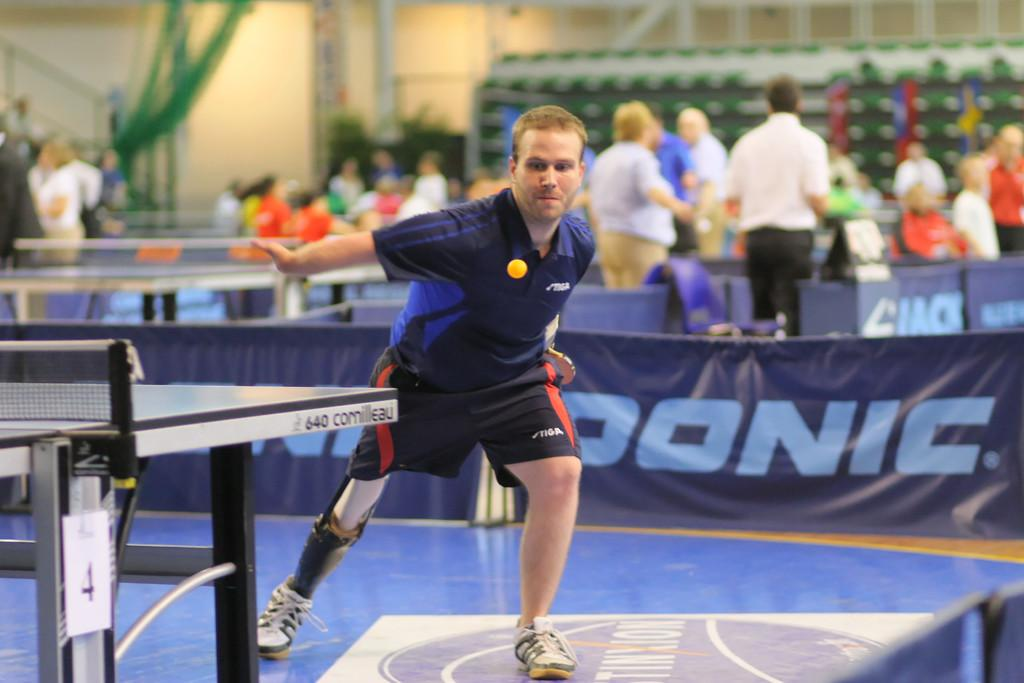Who or what can be seen in the image? There are people in the image. What else is present in the image besides people? There are banners and a table in the image. What type of structures can be seen in the background? There are buildings in the image. Can you describe the background of the image? The background of the image is slightly blurred. Is there an argument taking place between the people in the image? There is no indication of an argument in the image; it only shows people, banners, a table, and buildings. Can you see any icicles hanging from the buildings in the image? There is no mention of icicles in the provided facts, and therefore we cannot determine if any are present in the image. 